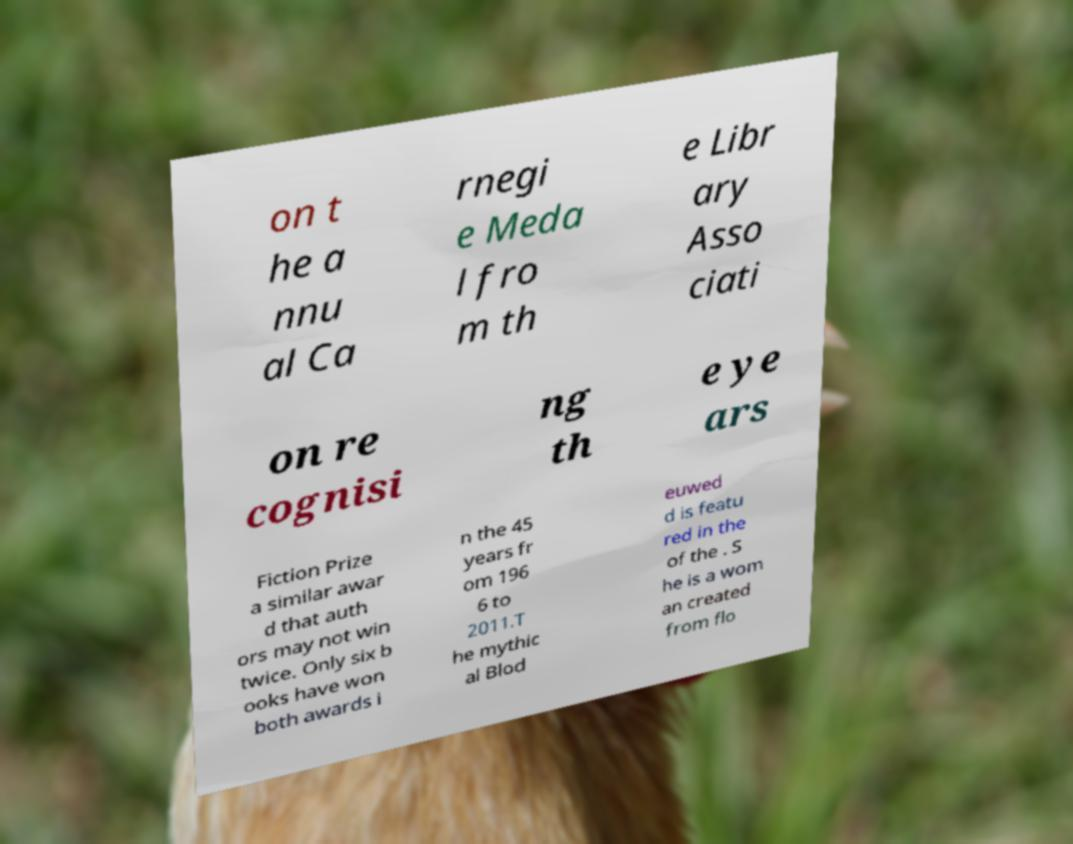What messages or text are displayed in this image? I need them in a readable, typed format. on t he a nnu al Ca rnegi e Meda l fro m th e Libr ary Asso ciati on re cognisi ng th e ye ars Fiction Prize a similar awar d that auth ors may not win twice. Only six b ooks have won both awards i n the 45 years fr om 196 6 to 2011.T he mythic al Blod euwed d is featu red in the of the . S he is a wom an created from flo 